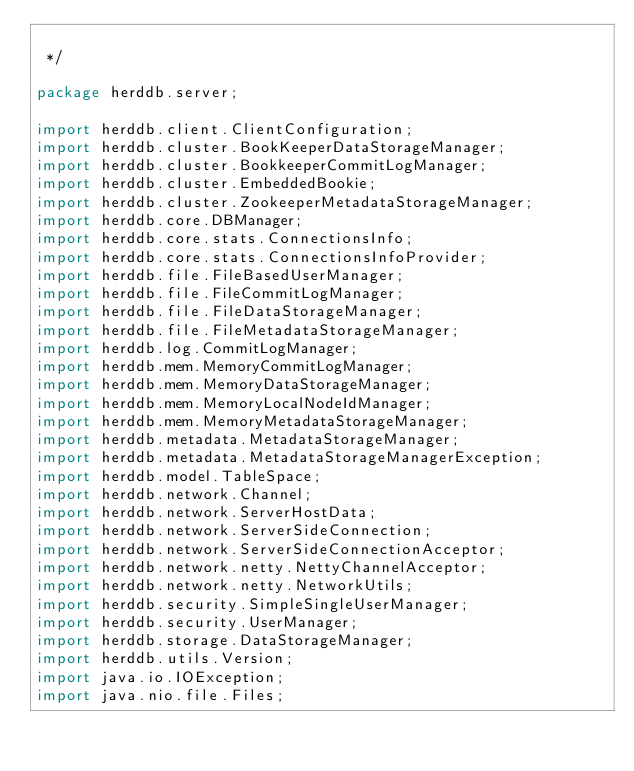Convert code to text. <code><loc_0><loc_0><loc_500><loc_500><_Java_>
 */

package herddb.server;

import herddb.client.ClientConfiguration;
import herddb.cluster.BookKeeperDataStorageManager;
import herddb.cluster.BookkeeperCommitLogManager;
import herddb.cluster.EmbeddedBookie;
import herddb.cluster.ZookeeperMetadataStorageManager;
import herddb.core.DBManager;
import herddb.core.stats.ConnectionsInfo;
import herddb.core.stats.ConnectionsInfoProvider;
import herddb.file.FileBasedUserManager;
import herddb.file.FileCommitLogManager;
import herddb.file.FileDataStorageManager;
import herddb.file.FileMetadataStorageManager;
import herddb.log.CommitLogManager;
import herddb.mem.MemoryCommitLogManager;
import herddb.mem.MemoryDataStorageManager;
import herddb.mem.MemoryLocalNodeIdManager;
import herddb.mem.MemoryMetadataStorageManager;
import herddb.metadata.MetadataStorageManager;
import herddb.metadata.MetadataStorageManagerException;
import herddb.model.TableSpace;
import herddb.network.Channel;
import herddb.network.ServerHostData;
import herddb.network.ServerSideConnection;
import herddb.network.ServerSideConnectionAcceptor;
import herddb.network.netty.NettyChannelAcceptor;
import herddb.network.netty.NetworkUtils;
import herddb.security.SimpleSingleUserManager;
import herddb.security.UserManager;
import herddb.storage.DataStorageManager;
import herddb.utils.Version;
import java.io.IOException;
import java.nio.file.Files;</code> 